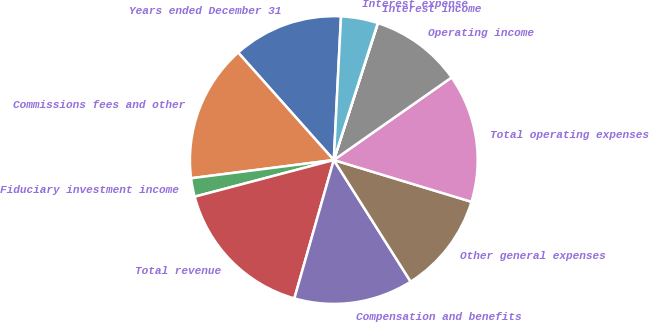Convert chart. <chart><loc_0><loc_0><loc_500><loc_500><pie_chart><fcel>Years ended December 31<fcel>Commissions fees and other<fcel>Fiduciary investment income<fcel>Total revenue<fcel>Compensation and benefits<fcel>Other general expenses<fcel>Total operating expenses<fcel>Operating income<fcel>Interest income<fcel>Interest expense<nl><fcel>12.37%<fcel>15.45%<fcel>2.08%<fcel>16.48%<fcel>13.39%<fcel>11.34%<fcel>14.42%<fcel>10.31%<fcel>0.02%<fcel>4.14%<nl></chart> 